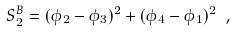Convert formula to latex. <formula><loc_0><loc_0><loc_500><loc_500>S _ { 2 } ^ { B } = ( \phi _ { 2 } - \phi _ { 3 } ) ^ { 2 } + ( \phi _ { 4 } - \phi _ { 1 } ) ^ { 2 } \ ,</formula> 